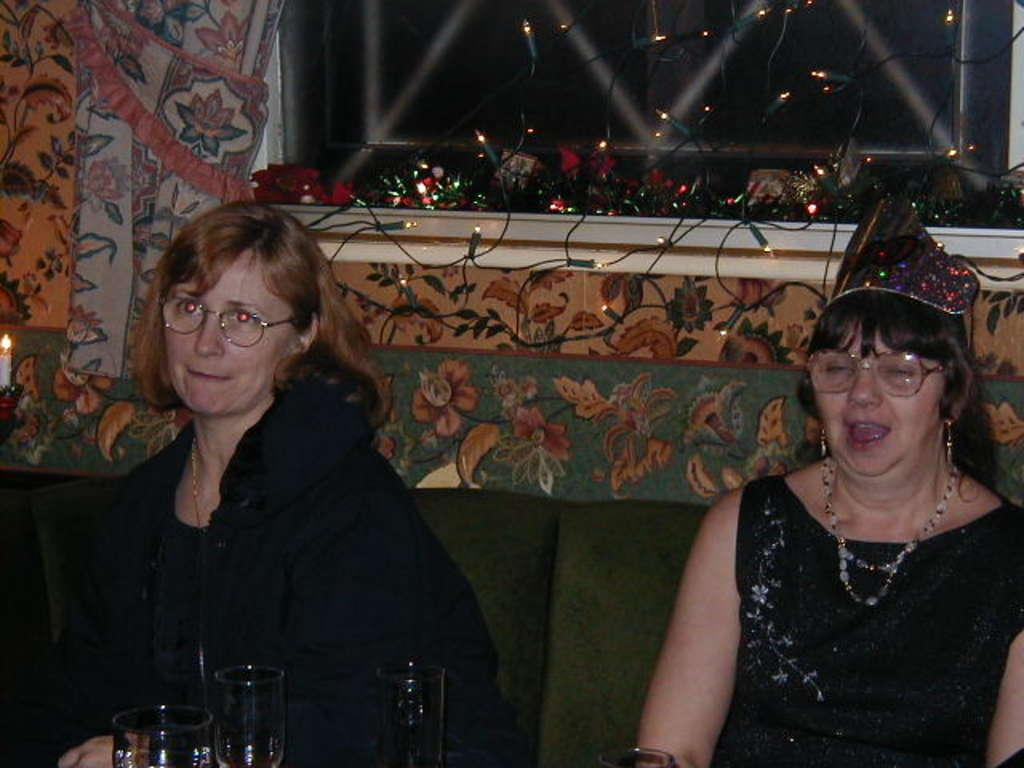How many women are in the image? There are two women in the image. What are the women doing in the image? The women are sitting on a sofa. What can be seen in the background of the image? There are curtains, decor lights, a window, a wall, and glass tumblers visible in the background of the image. What type of cub is playing with the women in the image? There is no cub present in the image; it features two women sitting on a sofa. How does the temper of the women change throughout the image? The image does not depict any changes in the women's temper; it simply shows them sitting on a sofa. 